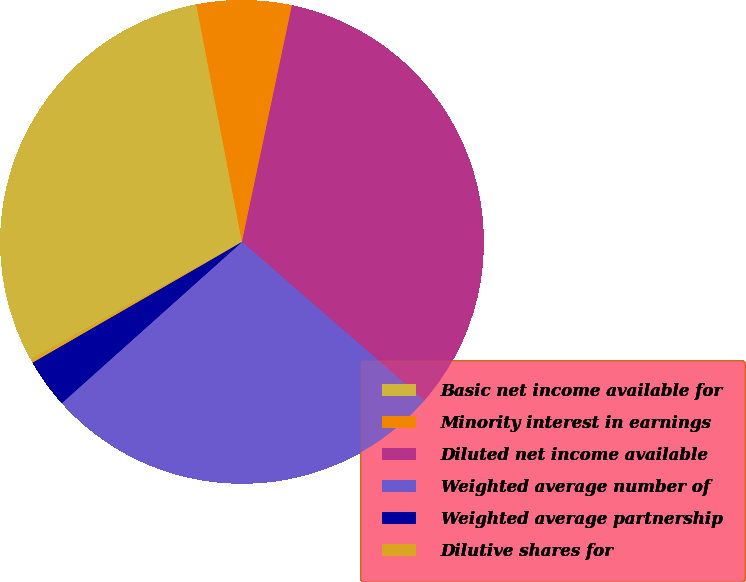Convert chart to OTSL. <chart><loc_0><loc_0><loc_500><loc_500><pie_chart><fcel>Basic net income available for<fcel>Minority interest in earnings<fcel>Diluted net income available<fcel>Weighted average number of<fcel>Weighted average partnership<fcel>Dilutive shares for<nl><fcel>30.04%<fcel>6.34%<fcel>33.08%<fcel>26.99%<fcel>3.3%<fcel>0.25%<nl></chart> 